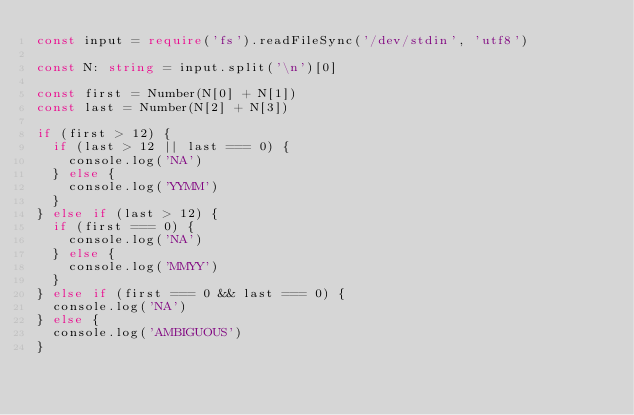Convert code to text. <code><loc_0><loc_0><loc_500><loc_500><_TypeScript_>const input = require('fs').readFileSync('/dev/stdin', 'utf8')

const N: string = input.split('\n')[0]

const first = Number(N[0] + N[1])
const last = Number(N[2] + N[3])

if (first > 12) {
  if (last > 12 || last === 0) {
    console.log('NA')
  } else {
    console.log('YYMM')
  }
} else if (last > 12) {
  if (first === 0) {
    console.log('NA')
  } else {
    console.log('MMYY')
  }
} else if (first === 0 && last === 0) {
  console.log('NA')
} else {
  console.log('AMBIGUOUS')
}</code> 